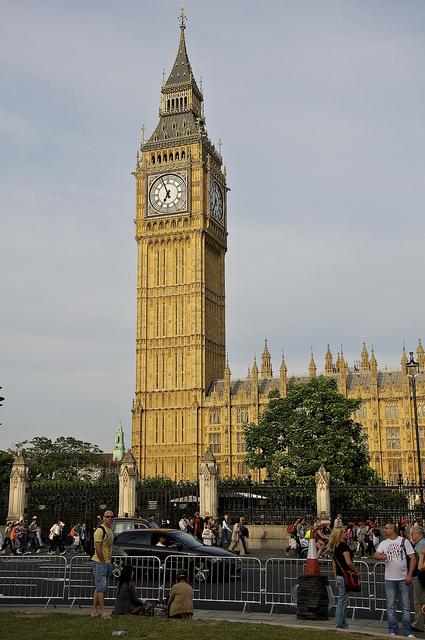Could the tower be a church?
Be succinct. Yes. Where is Big Ben?
Answer briefly. London. What is the nickname of this building?
Give a very brief answer. Big ben. What is the man doing?
Short answer required. Standing. How do you know this is in a warm climate?
Write a very short answer. T-shirts. Are there people visible?
Answer briefly. Yes. Is the picture of the olden days?
Give a very brief answer. No. Are there any clouds in the sky?
Be succinct. Yes. What time is it?
Write a very short answer. 6:55. What does the clock say?
Write a very short answer. 6:55. Can you see people in this picture?
Concise answer only. Yes. 